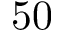<formula> <loc_0><loc_0><loc_500><loc_500>5 0</formula> 